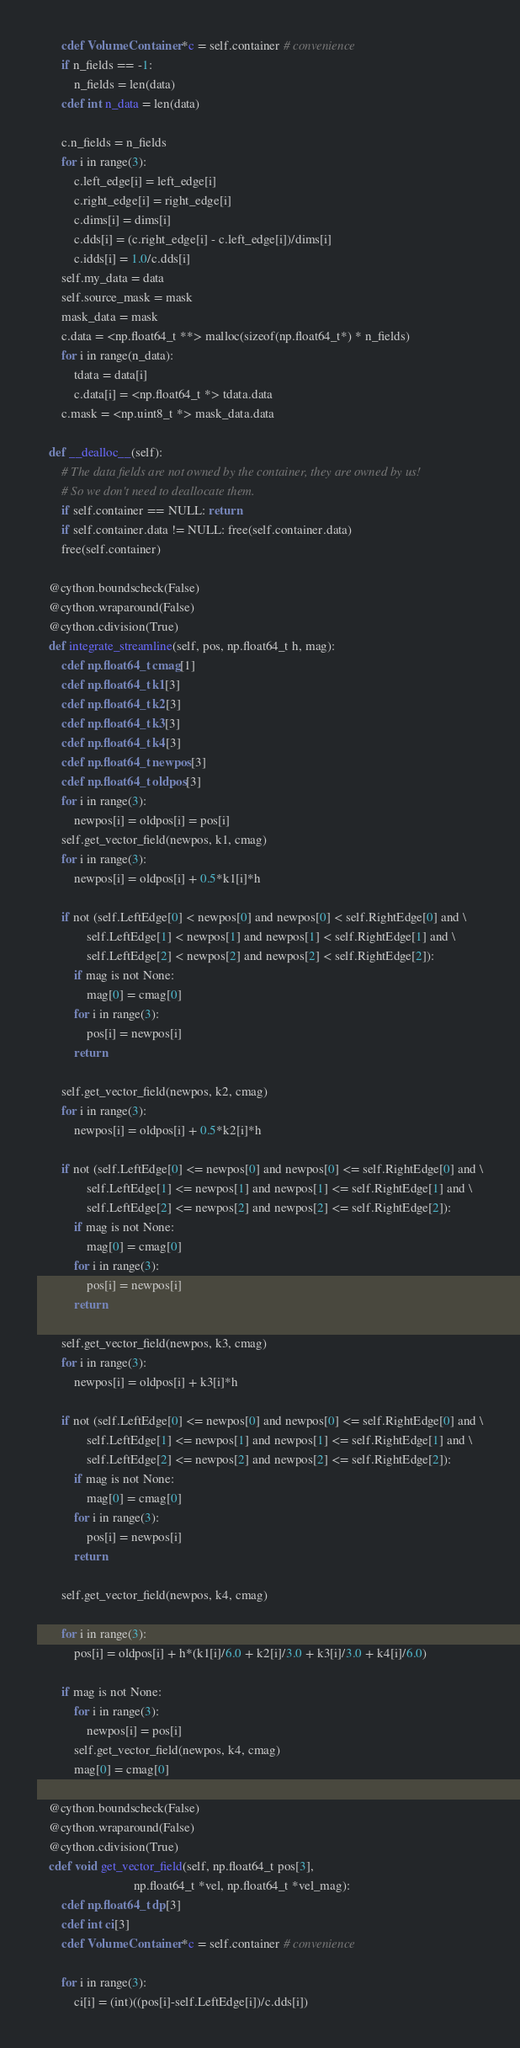Convert code to text. <code><loc_0><loc_0><loc_500><loc_500><_Cython_>        cdef VolumeContainer *c = self.container # convenience
        if n_fields == -1:
            n_fields = len(data)
        cdef int n_data = len(data)

        c.n_fields = n_fields
        for i in range(3):
            c.left_edge[i] = left_edge[i]
            c.right_edge[i] = right_edge[i]
            c.dims[i] = dims[i]
            c.dds[i] = (c.right_edge[i] - c.left_edge[i])/dims[i]
            c.idds[i] = 1.0/c.dds[i]
        self.my_data = data
        self.source_mask = mask
        mask_data = mask
        c.data = <np.float64_t **> malloc(sizeof(np.float64_t*) * n_fields)
        for i in range(n_data):
            tdata = data[i]
            c.data[i] = <np.float64_t *> tdata.data
        c.mask = <np.uint8_t *> mask_data.data

    def __dealloc__(self):
        # The data fields are not owned by the container, they are owned by us!
        # So we don't need to deallocate them.
        if self.container == NULL: return
        if self.container.data != NULL: free(self.container.data)
        free(self.container)

    @cython.boundscheck(False)
    @cython.wraparound(False)
    @cython.cdivision(True)
    def integrate_streamline(self, pos, np.float64_t h, mag):
        cdef np.float64_t cmag[1]
        cdef np.float64_t k1[3]
        cdef np.float64_t k2[3]
        cdef np.float64_t k3[3]
        cdef np.float64_t k4[3]
        cdef np.float64_t newpos[3]
        cdef np.float64_t oldpos[3]
        for i in range(3):
            newpos[i] = oldpos[i] = pos[i]
        self.get_vector_field(newpos, k1, cmag)
        for i in range(3):
            newpos[i] = oldpos[i] + 0.5*k1[i]*h

        if not (self.LeftEdge[0] < newpos[0] and newpos[0] < self.RightEdge[0] and \
                self.LeftEdge[1] < newpos[1] and newpos[1] < self.RightEdge[1] and \
                self.LeftEdge[2] < newpos[2] and newpos[2] < self.RightEdge[2]):
            if mag is not None:
                mag[0] = cmag[0]
            for i in range(3):
                pos[i] = newpos[i]
            return

        self.get_vector_field(newpos, k2, cmag)
        for i in range(3):
            newpos[i] = oldpos[i] + 0.5*k2[i]*h

        if not (self.LeftEdge[0] <= newpos[0] and newpos[0] <= self.RightEdge[0] and \
                self.LeftEdge[1] <= newpos[1] and newpos[1] <= self.RightEdge[1] and \
                self.LeftEdge[2] <= newpos[2] and newpos[2] <= self.RightEdge[2]):
            if mag is not None:
                mag[0] = cmag[0]
            for i in range(3):
                pos[i] = newpos[i]
            return

        self.get_vector_field(newpos, k3, cmag)
        for i in range(3):
            newpos[i] = oldpos[i] + k3[i]*h

        if not (self.LeftEdge[0] <= newpos[0] and newpos[0] <= self.RightEdge[0] and \
                self.LeftEdge[1] <= newpos[1] and newpos[1] <= self.RightEdge[1] and \
                self.LeftEdge[2] <= newpos[2] and newpos[2] <= self.RightEdge[2]):
            if mag is not None:
                mag[0] = cmag[0]
            for i in range(3):
                pos[i] = newpos[i]
            return

        self.get_vector_field(newpos, k4, cmag)

        for i in range(3):
            pos[i] = oldpos[i] + h*(k1[i]/6.0 + k2[i]/3.0 + k3[i]/3.0 + k4[i]/6.0)

        if mag is not None:
            for i in range(3):
                newpos[i] = pos[i]
            self.get_vector_field(newpos, k4, cmag)
            mag[0] = cmag[0]

    @cython.boundscheck(False)
    @cython.wraparound(False)
    @cython.cdivision(True)
    cdef void get_vector_field(self, np.float64_t pos[3],
                               np.float64_t *vel, np.float64_t *vel_mag):
        cdef np.float64_t dp[3]
        cdef int ci[3]
        cdef VolumeContainer *c = self.container # convenience

        for i in range(3):
            ci[i] = (int)((pos[i]-self.LeftEdge[i])/c.dds[i])</code> 